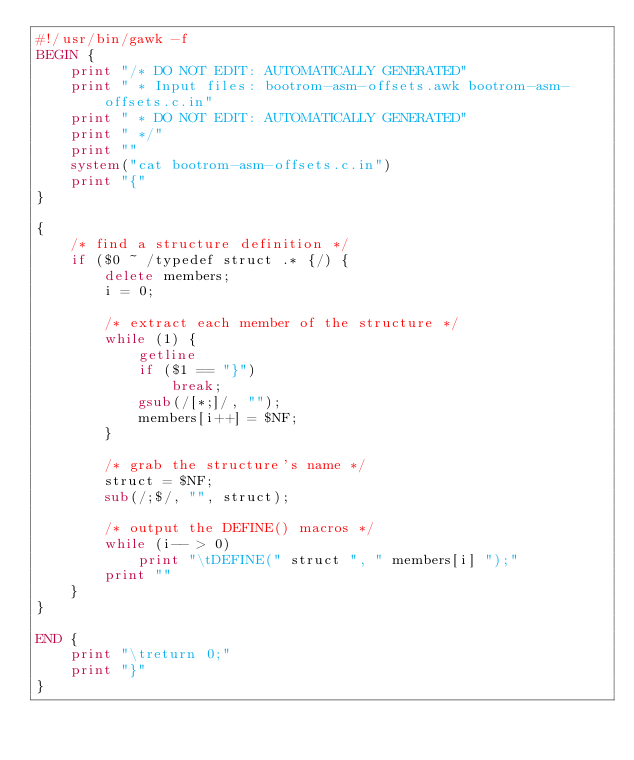<code> <loc_0><loc_0><loc_500><loc_500><_Awk_>#!/usr/bin/gawk -f
BEGIN {
	print "/* DO NOT EDIT: AUTOMATICALLY GENERATED"
	print " * Input files: bootrom-asm-offsets.awk bootrom-asm-offsets.c.in"
	print " * DO NOT EDIT: AUTOMATICALLY GENERATED"
	print " */"
	print ""
	system("cat bootrom-asm-offsets.c.in")
	print "{"
}

{
	/* find a structure definition */
	if ($0 ~ /typedef struct .* {/) {
		delete members;
		i = 0;

		/* extract each member of the structure */
		while (1) {
			getline
			if ($1 == "}")
				break;
			gsub(/[*;]/, "");
			members[i++] = $NF;
		}

		/* grab the structure's name */
		struct = $NF;
		sub(/;$/, "", struct);

		/* output the DEFINE() macros */
		while (i-- > 0)
			print "\tDEFINE(" struct ", " members[i] ");"
		print ""
	}
}

END {
	print "\treturn 0;"
	print "}"
}
</code> 